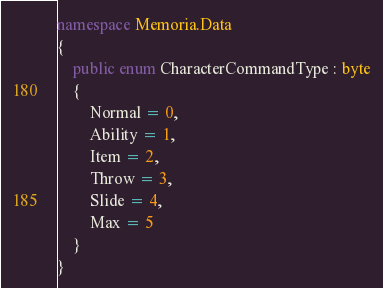<code> <loc_0><loc_0><loc_500><loc_500><_C#_>namespace Memoria.Data
{
    public enum CharacterCommandType : byte
    {
        Normal = 0,
        Ability = 1,
        Item = 2,
        Throw = 3,
        Slide = 4,
        Max = 5
    }
}</code> 